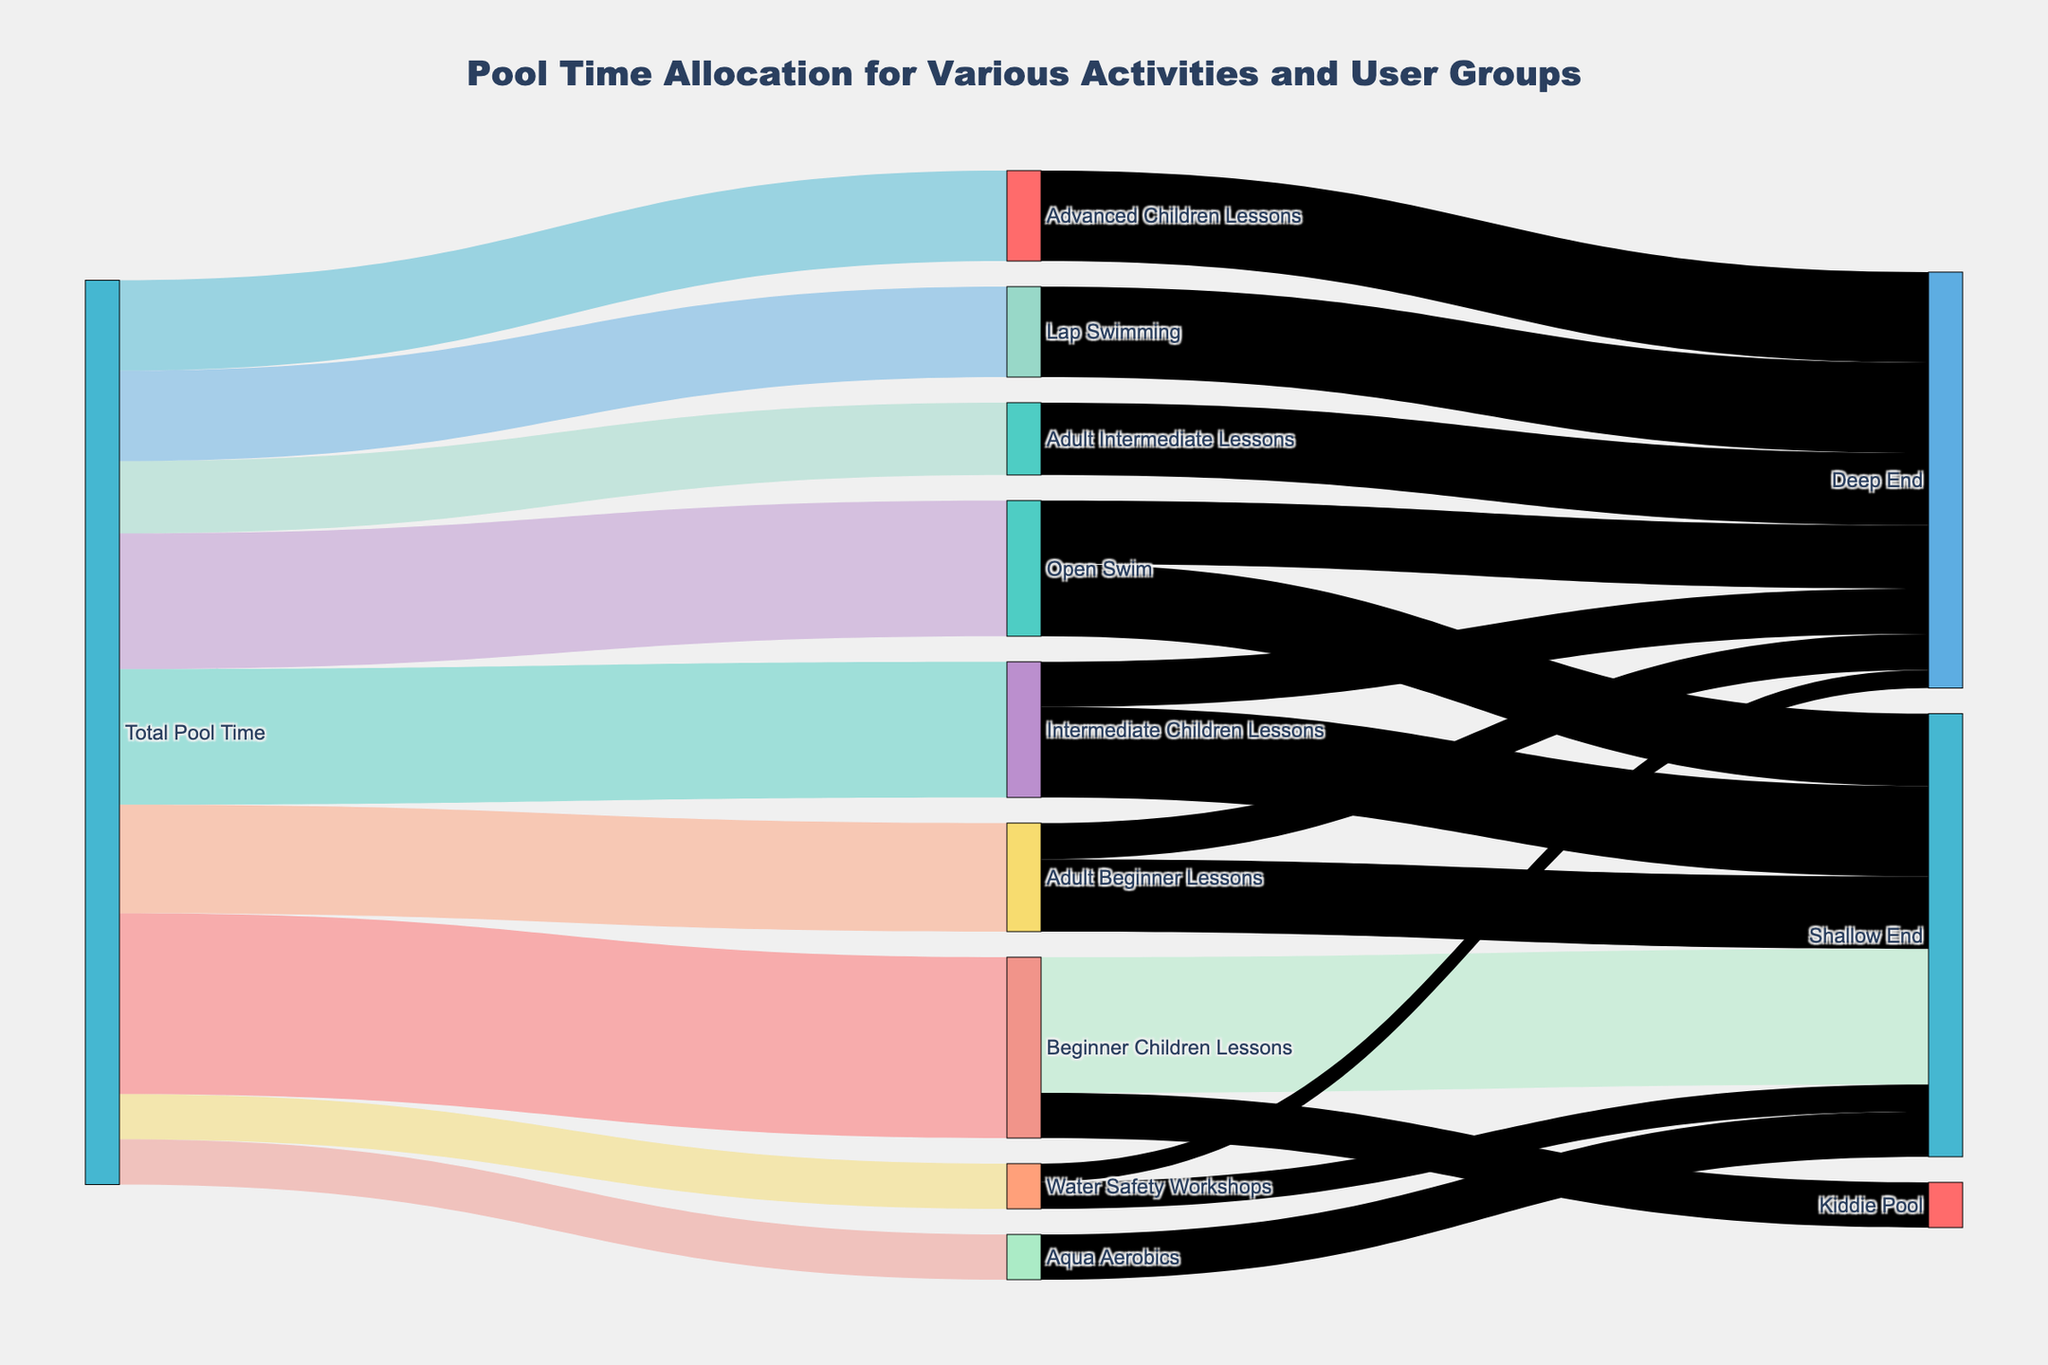What's the total pool time allocated for beginner children lessons? First, identify the "Beginner Children Lessons" node. Follow the link connecting "Total Pool Time" to "Beginner Children Lessons" which shows the value 20.
Answer: 20 Which activity has the highest pool time allocation? Identify the largest number connected to the "Total Pool Time" node. The largest value is 20, which connects to "Beginner Children Lessons".
Answer: Beginner Children Lessons How much pool time is spent in the shallow end for open swim? Locate the "Open Swim" node and find the link to the "Shallow End" node, which shows the value 8.
Answer: 8 Compare the pool time allocation between adult beginner lessons and adult intermediate lessons. Find the values connecting "Total Pool Time" to "Adult Beginner Lessons" (12) and "Adult Intermediate Lessons" (8). Compare these values.
Answer: Adult Beginner Lessons: 12, Adult Intermediate Lessons: 8 What is the total pool time spent in the deep end for all activities combined? Add the values from nodes connected to the "Deep End": Intermediate Children Lessons (5), Advanced Children Lessons (10), Adult Beginner Lessons (4), Adult Intermediate Lessons (8), Water Safety Workshops (2), Open Swim (7), and Lap Swimming (10). Total is 5 + 10 + 4 + 8 + 2 + 7 + 10 = 46.
Answer: 46 Which user group uses the deep end the most? Check all nodes connected to the "Deep End" and compare their values. The largest value connected to "Deep End" is from "Lap Swimming" with a value of 10.
Answer: Lap Swimming How much allocation is there for water safety workshops in comparison to aqua aerobics? Find the values for both nodes connected to "Total Pool Time". Water Safety Workshops is 5, Aqua Aerobics is 5.
Answer: Both are 5 In total, how much pool time is allocated for children (beginner, intermediate, advanced lessons)? Sum the values from nodes connected to "Total Pool Time" for children groups (20 + 15 + 10). Total is 20 + 15 + 10 = 45.
Answer: 45 What percentage of the total pool time is dedicated to lap swimming? Identify the value for "Lap Swimming" (10) and the total pool time value (95; sum of all values connected to "Total Pool Time"). Calculate the percentage: (10 / 95) * 100 ≈ 10.53%.
Answer: ~10.53% Is more pool time allocated to beginner children lessons compared to open swim and lap swimming combined? Compare the value for "Beginner Children Lessons" (20) to the combined value of "Open Swim" (15) and "Lap Swimming" (10). Combined, Open Swim and Lap Swimming is 15 + 10 = 25.
Answer: No 